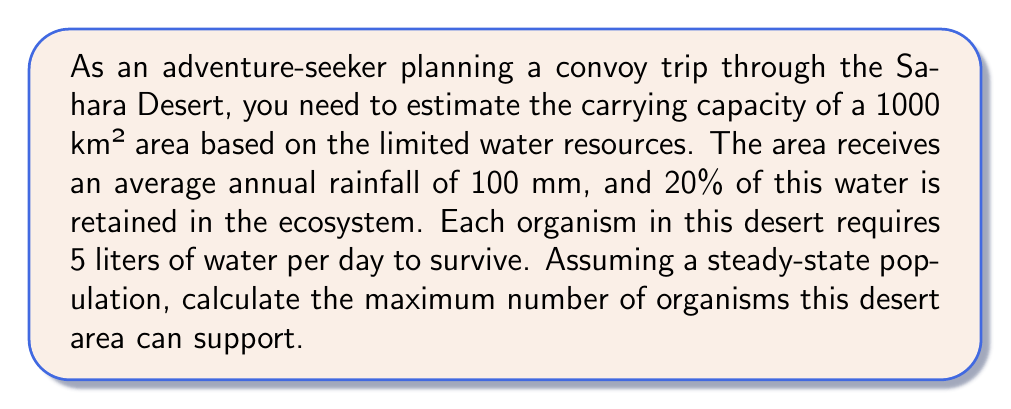Can you answer this question? To solve this problem, we need to follow these steps:

1. Calculate the total volume of water available annually:
   - Area = 1000 km² = 1,000,000,000 m²
   - Annual rainfall = 100 mm = 0.1 m
   - Total water volume = Area × Rainfall
   $$V_{total} = 1,000,000,000 \text{ m}^2 \times 0.1 \text{ m} = 100,000,000 \text{ m}^3$$

2. Calculate the retained water volume:
   - Retained water percentage = 20% = 0.2
   $$V_{retained} = V_{total} \times 0.2 = 100,000,000 \text{ m}^3 \times 0.2 = 20,000,000 \text{ m}^3$$

3. Convert the retained water volume to liters:
   $$V_{liters} = 20,000,000 \text{ m}^3 \times 1000 \text{ L/m}^3 = 20,000,000,000 \text{ L}$$

4. Calculate the daily water requirement per organism:
   $$W_{daily} = 5 \text{ L/organism/day}$$

5. Calculate the annual water requirement per organism:
   $$W_{annual} = W_{daily} \times 365 \text{ days} = 5 \text{ L/organism/day} \times 365 \text{ days} = 1825 \text{ L/organism/year}$$

6. Calculate the carrying capacity (maximum number of organisms):
   $$K = \frac{V_{liters}}{W_{annual}} = \frac{20,000,000,000 \text{ L}}{1825 \text{ L/organism}} \approx 10,958,904 \text{ organisms}$$

Therefore, the carrying capacity of this desert area is approximately 10,958,904 organisms.
Answer: The maximum number of organisms this desert area can support (carrying capacity) is approximately 10,958,904. 